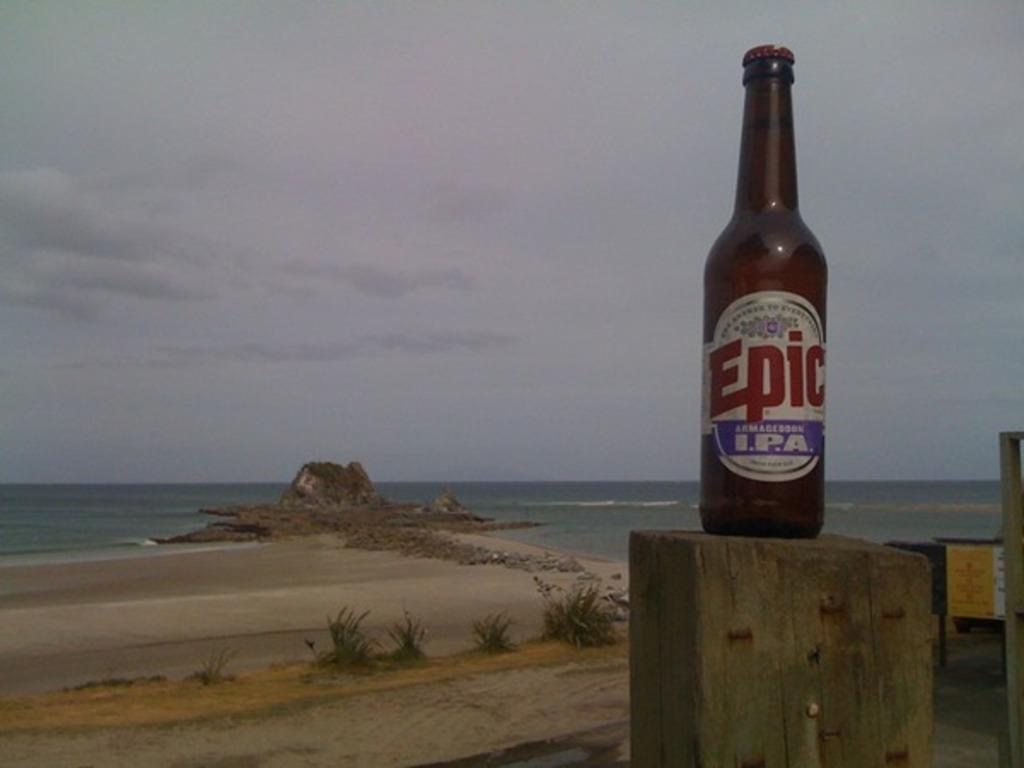<image>
Provide a brief description of the given image. An empty bottle of epic branded IPA alcohol on top of a wooden column. 